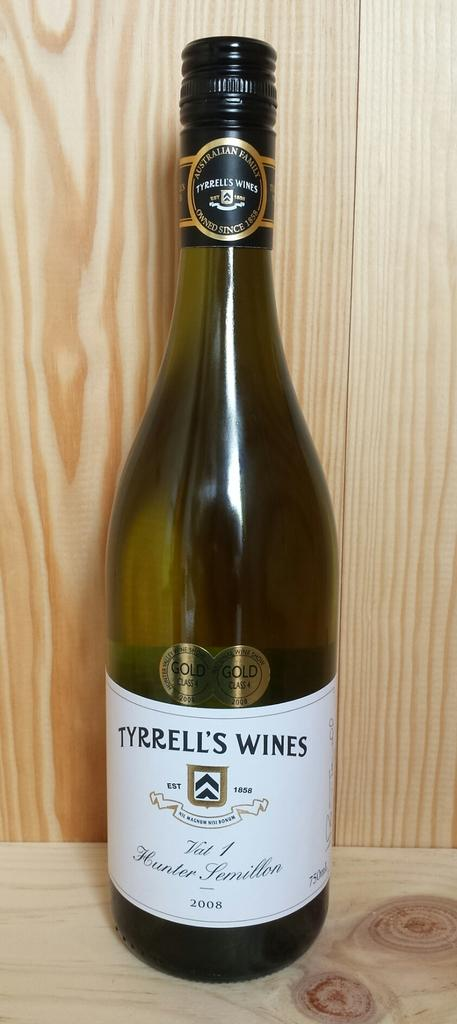Provide a one-sentence caption for the provided image. A bottle of white wine with the name Tyrell's on it. 